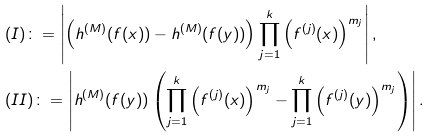<formula> <loc_0><loc_0><loc_500><loc_500>& ( I ) \colon = \left | \left ( h ^ { ( M ) } ( f ( x ) ) - h ^ { ( M ) } ( f ( y ) ) \right ) \prod _ { j = 1 } ^ { k } \left ( f ^ { ( j ) } ( x ) \right ) ^ { m _ { j } } \right | , \\ & ( I I ) \colon = \left | h ^ { ( M ) } ( f ( y ) ) \left ( \prod _ { j = 1 } ^ { k } \left ( f ^ { ( j ) } ( x ) \right ) ^ { m _ { j } } - \prod _ { j = 1 } ^ { k } \left ( f ^ { ( j ) } ( y ) \right ) ^ { m _ { j } } \right ) \right | .</formula> 